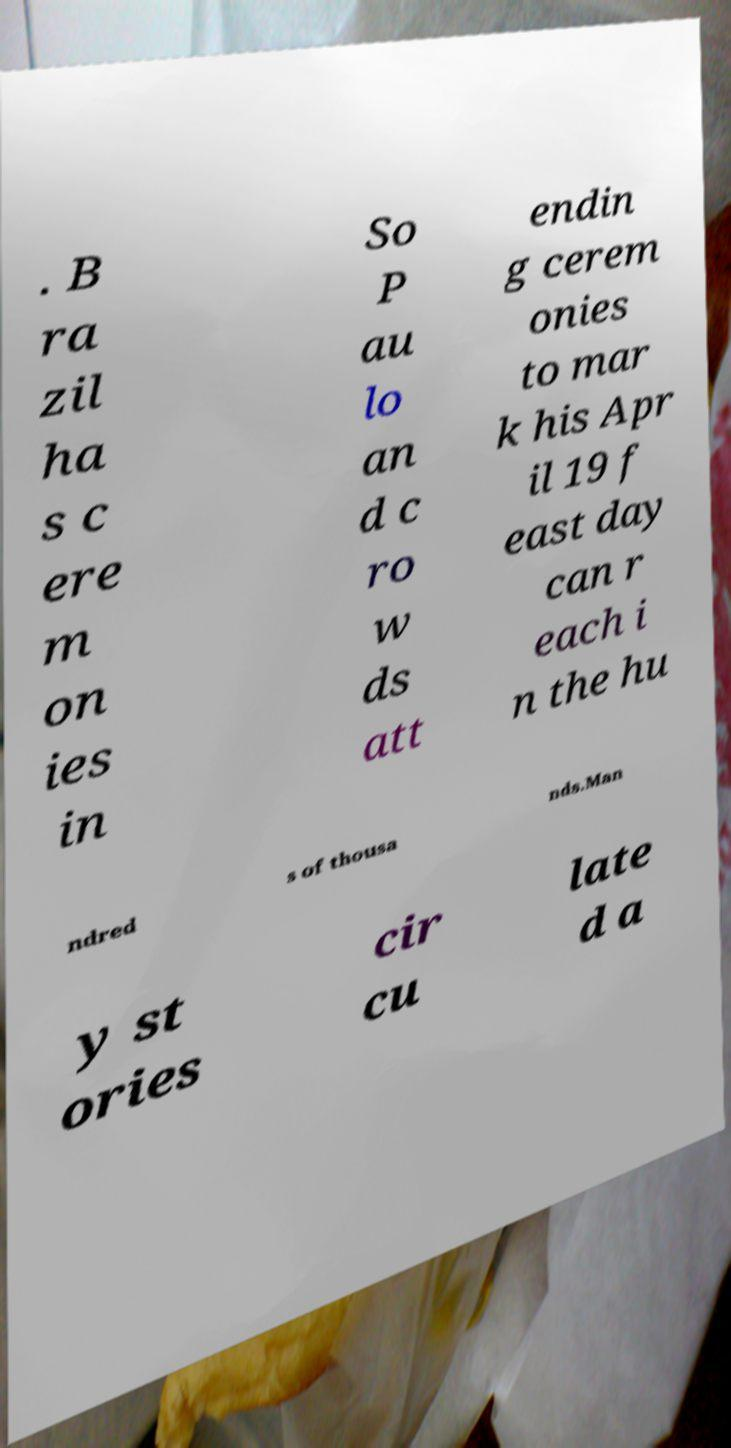For documentation purposes, I need the text within this image transcribed. Could you provide that? . B ra zil ha s c ere m on ies in So P au lo an d c ro w ds att endin g cerem onies to mar k his Apr il 19 f east day can r each i n the hu ndred s of thousa nds.Man y st ories cir cu late d a 